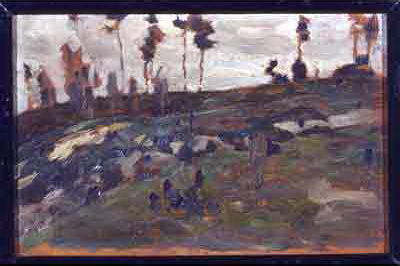Describe the lighting conditions in this painting. The lighting in the painting is depicted as soft and diffused, likely representing an overcast or late afternoon scene. The absence of strong shadows and the subdued highlights contribute to the overall somber and contemplative atmosphere of the landscape. How do the colors in the painting influence its mood? The colors in the painting—predominantly dark and earthy tones interspersed with hints of blue and green—play a crucial role in shaping its mood. These muted, natural colors lend a sense of quietness and introspection to the scene, reinforcing the tranquil and reflective atmosphere of the landscape. Imagine the scene in the painting as a setting for a novel. What is the opening line? "As the last light of day melted into the brooding twilight, the rocky hillside stood resilient, its silence broken only by the whisper of the worn, ancient trees swaying in the evening breeze." Can you describe a specific, realistic scenario depicted in this landscape? A lone wanderer ascends the rocky terrain, his steps slow and deliberate as he pauses to take in the muted beauty of the hillside. The overcast sky casts a gentle light over the subdued colors of the landscape, making the scene appear timeless and tranquil. Could it be dawn, given the lighting and colors? While it's plausible to interpret the scene as dawn, the overall muted quality of the light and subdued color palette suggest it is more likely capturing the quiet, contemplative mood of dusk or an overcast day rather than the burgeoning energy of morning. 